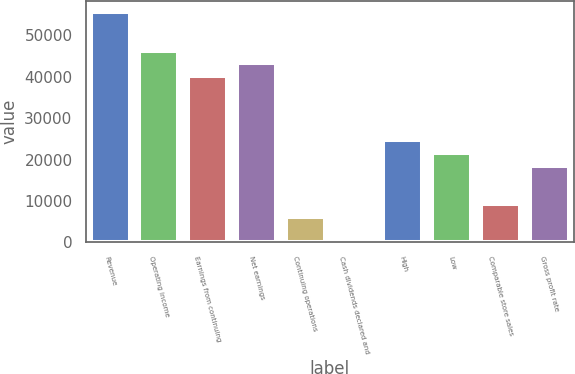Convert chart to OTSL. <chart><loc_0><loc_0><loc_500><loc_500><bar_chart><fcel>Revenue<fcel>Operating income<fcel>Earnings from continuing<fcel>Net earnings<fcel>Continuing operations<fcel>Cash dividends declared and<fcel>High<fcel>Low<fcel>Comparable store sales<fcel>Gross profit rate<nl><fcel>55526.2<fcel>46271.9<fcel>40102.3<fcel>43187.1<fcel>6169.85<fcel>0.31<fcel>24678.5<fcel>21593.7<fcel>9254.62<fcel>18508.9<nl></chart> 